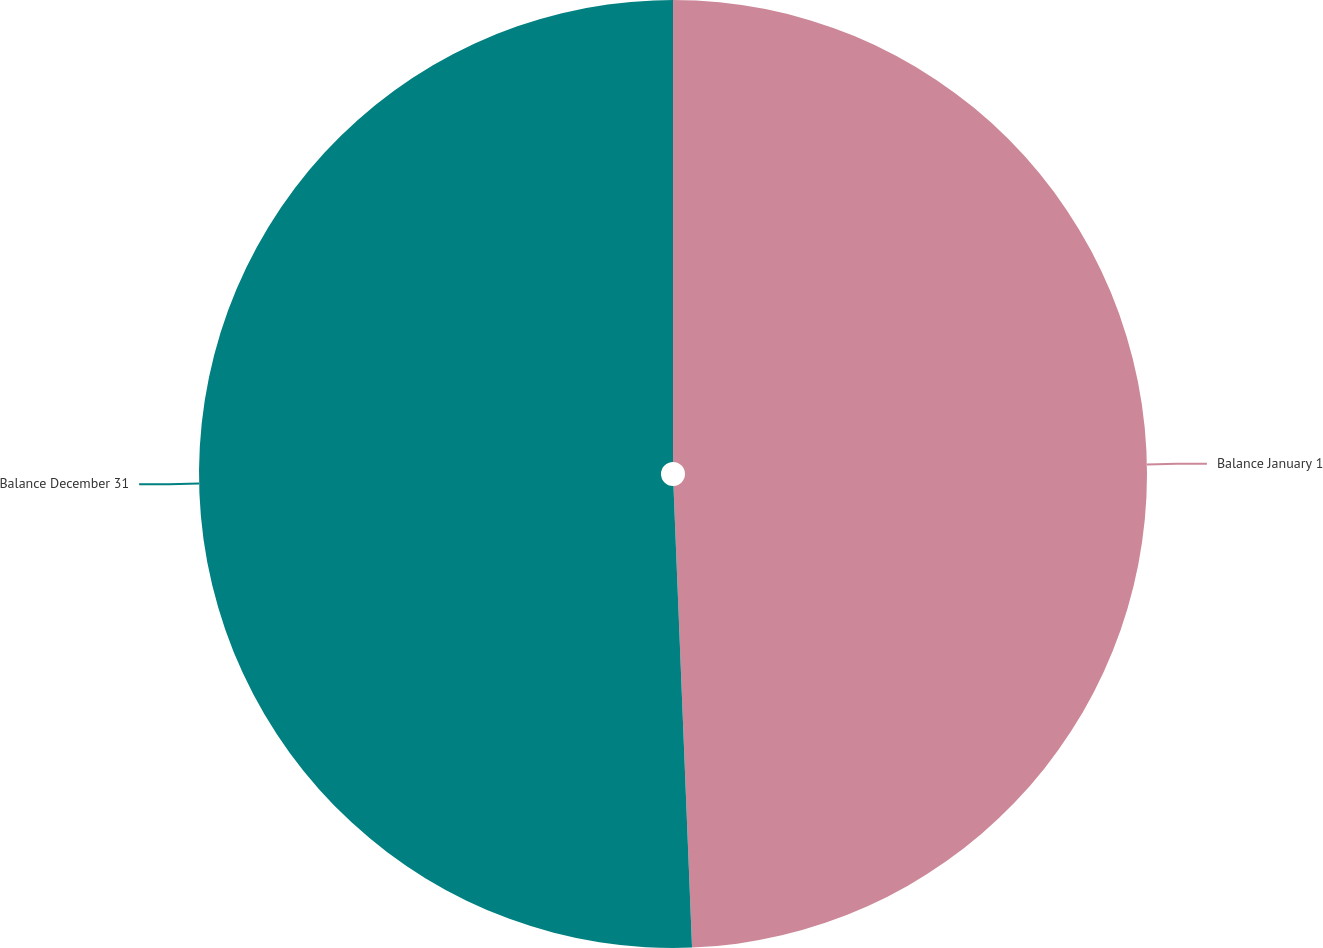Convert chart. <chart><loc_0><loc_0><loc_500><loc_500><pie_chart><fcel>Balance January 1<fcel>Balance December 31<nl><fcel>49.36%<fcel>50.64%<nl></chart> 